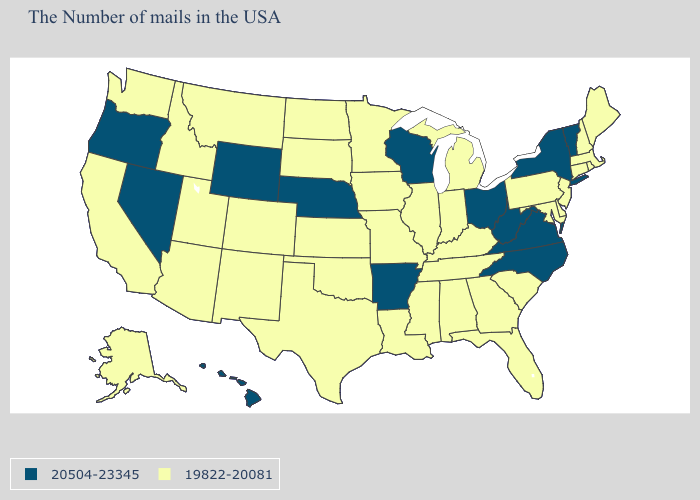Name the states that have a value in the range 20504-23345?
Give a very brief answer. Vermont, New York, Virginia, North Carolina, West Virginia, Ohio, Wisconsin, Arkansas, Nebraska, Wyoming, Nevada, Oregon, Hawaii. Does Virginia have the highest value in the South?
Short answer required. Yes. How many symbols are there in the legend?
Quick response, please. 2. Name the states that have a value in the range 20504-23345?
Answer briefly. Vermont, New York, Virginia, North Carolina, West Virginia, Ohio, Wisconsin, Arkansas, Nebraska, Wyoming, Nevada, Oregon, Hawaii. What is the value of Michigan?
Write a very short answer. 19822-20081. Name the states that have a value in the range 20504-23345?
Write a very short answer. Vermont, New York, Virginia, North Carolina, West Virginia, Ohio, Wisconsin, Arkansas, Nebraska, Wyoming, Nevada, Oregon, Hawaii. Among the states that border Pennsylvania , which have the highest value?
Quick response, please. New York, West Virginia, Ohio. Does Florida have the highest value in the USA?
Give a very brief answer. No. Name the states that have a value in the range 20504-23345?
Short answer required. Vermont, New York, Virginia, North Carolina, West Virginia, Ohio, Wisconsin, Arkansas, Nebraska, Wyoming, Nevada, Oregon, Hawaii. Which states hav the highest value in the Northeast?
Quick response, please. Vermont, New York. What is the highest value in the USA?
Give a very brief answer. 20504-23345. What is the highest value in the West ?
Give a very brief answer. 20504-23345. Does New Jersey have a lower value than Tennessee?
Answer briefly. No. Name the states that have a value in the range 19822-20081?
Quick response, please. Maine, Massachusetts, Rhode Island, New Hampshire, Connecticut, New Jersey, Delaware, Maryland, Pennsylvania, South Carolina, Florida, Georgia, Michigan, Kentucky, Indiana, Alabama, Tennessee, Illinois, Mississippi, Louisiana, Missouri, Minnesota, Iowa, Kansas, Oklahoma, Texas, South Dakota, North Dakota, Colorado, New Mexico, Utah, Montana, Arizona, Idaho, California, Washington, Alaska. 